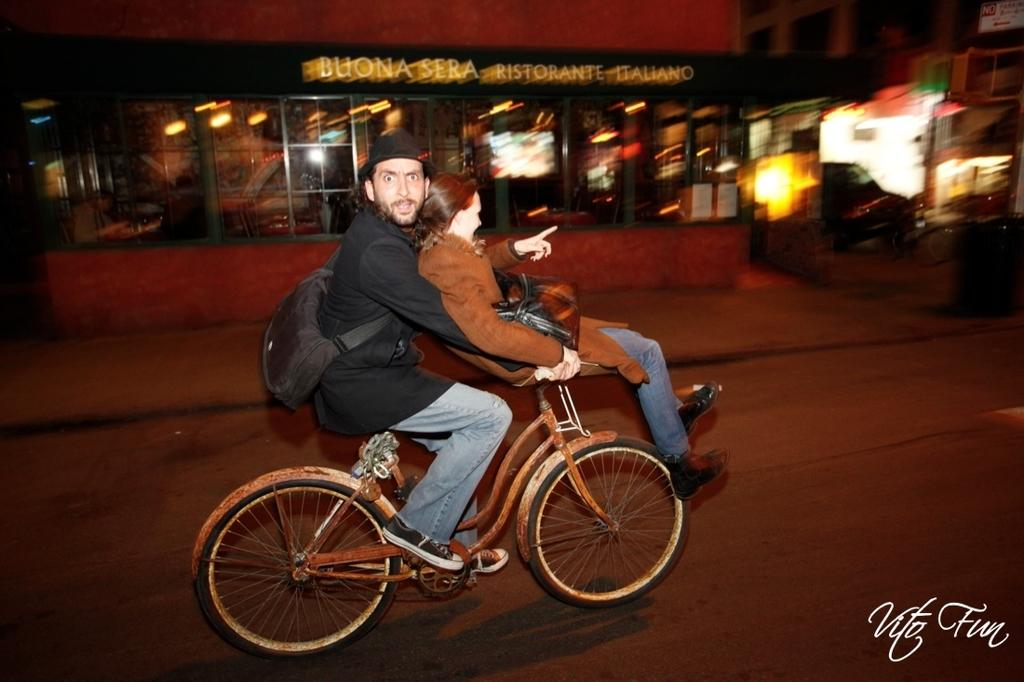What is the man in the image doing? The man is sitting on a cycle in the image. Who is with the man in the image? There is a girl beside the man in the image. What can be seen in the background of the image? There is a store visible in the image, and a building on the right side of the image. What type of thread is being used by the man to improve his health in the image? There is no thread or reference to health improvement in the image; the man is simply sitting on a cycle. 